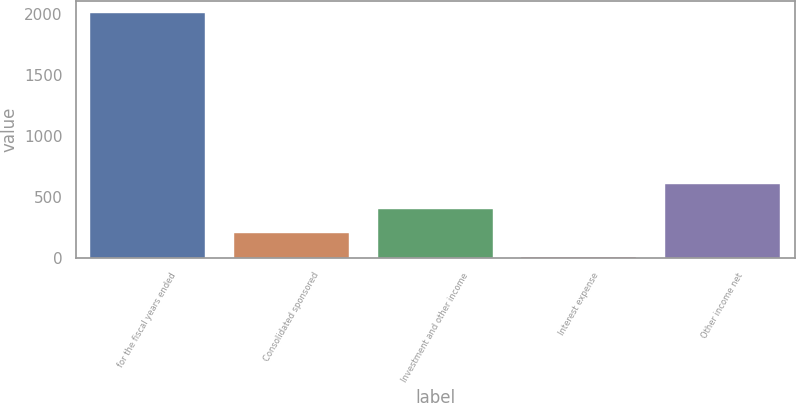<chart> <loc_0><loc_0><loc_500><loc_500><bar_chart><fcel>for the fiscal years ended<fcel>Consolidated sponsored<fcel>Investment and other income<fcel>Interest expense<fcel>Other income net<nl><fcel>2009<fcel>204.32<fcel>404.84<fcel>3.8<fcel>605.36<nl></chart> 